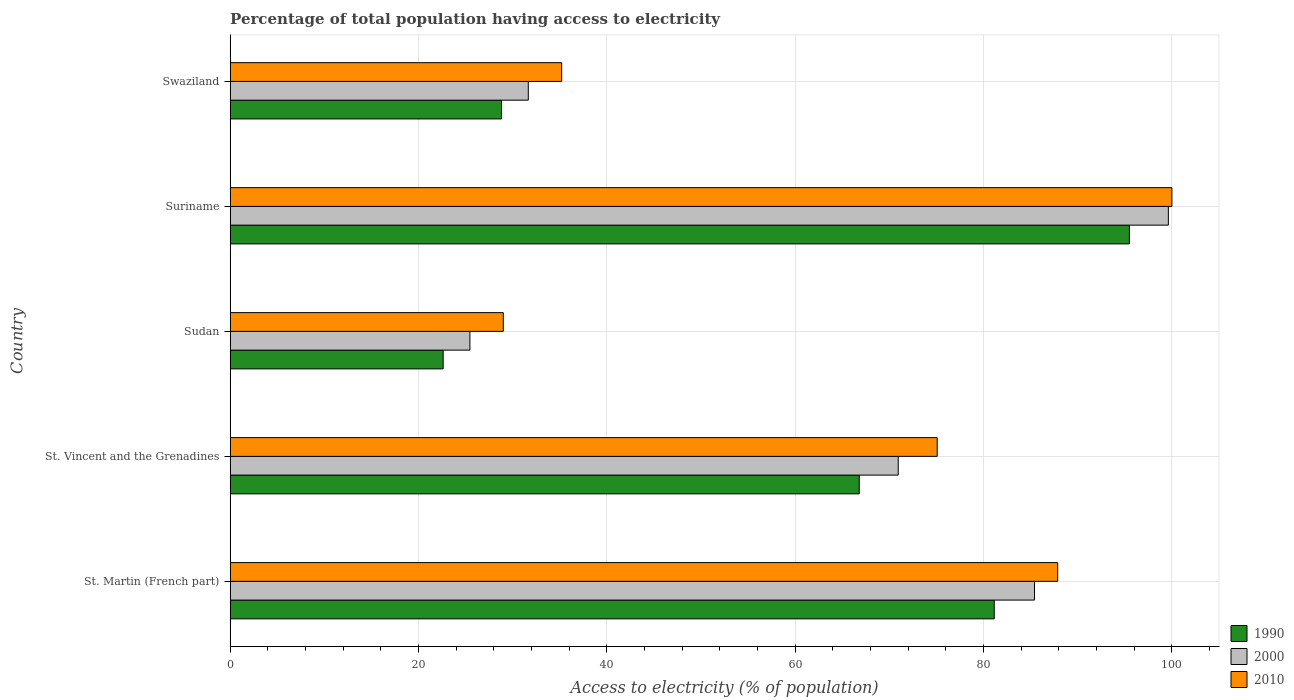How many bars are there on the 5th tick from the bottom?
Give a very brief answer. 3. What is the label of the 2nd group of bars from the top?
Give a very brief answer. Suriname. In how many cases, is the number of bars for a given country not equal to the number of legend labels?
Offer a very short reply. 0. What is the percentage of population that have access to electricity in 2000 in St. Vincent and the Grenadines?
Your response must be concise. 70.94. Across all countries, what is the maximum percentage of population that have access to electricity in 2010?
Offer a terse response. 100. Across all countries, what is the minimum percentage of population that have access to electricity in 1990?
Provide a short and direct response. 22.62. In which country was the percentage of population that have access to electricity in 1990 maximum?
Provide a succinct answer. Suriname. In which country was the percentage of population that have access to electricity in 2010 minimum?
Give a very brief answer. Sudan. What is the total percentage of population that have access to electricity in 1990 in the graph?
Offer a terse response. 294.85. What is the difference between the percentage of population that have access to electricity in 2010 in St. Vincent and the Grenadines and that in Suriname?
Give a very brief answer. -24.92. What is the difference between the percentage of population that have access to electricity in 1990 in Sudan and the percentage of population that have access to electricity in 2010 in St. Vincent and the Grenadines?
Make the answer very short. -52.46. What is the average percentage of population that have access to electricity in 2010 per country?
Offer a very short reply. 65.43. What is the difference between the percentage of population that have access to electricity in 1990 and percentage of population that have access to electricity in 2000 in St. Martin (French part)?
Make the answer very short. -4.28. What is the ratio of the percentage of population that have access to electricity in 2010 in Sudan to that in Suriname?
Make the answer very short. 0.29. Is the percentage of population that have access to electricity in 2010 in Suriname less than that in Swaziland?
Your answer should be very brief. No. What is the difference between the highest and the second highest percentage of population that have access to electricity in 1990?
Ensure brevity in your answer.  14.35. What is the difference between the highest and the lowest percentage of population that have access to electricity in 2010?
Give a very brief answer. 71. Is the sum of the percentage of population that have access to electricity in 2000 in St. Vincent and the Grenadines and Sudan greater than the maximum percentage of population that have access to electricity in 2010 across all countries?
Make the answer very short. No. What does the 1st bar from the top in Swaziland represents?
Make the answer very short. 2010. What does the 2nd bar from the bottom in St. Vincent and the Grenadines represents?
Your answer should be compact. 2000. Are all the bars in the graph horizontal?
Your answer should be very brief. Yes. What is the difference between two consecutive major ticks on the X-axis?
Provide a short and direct response. 20. Does the graph contain any zero values?
Your response must be concise. No. Where does the legend appear in the graph?
Make the answer very short. Bottom right. How are the legend labels stacked?
Make the answer very short. Vertical. What is the title of the graph?
Offer a terse response. Percentage of total population having access to electricity. What is the label or title of the X-axis?
Your answer should be very brief. Access to electricity (% of population). What is the Access to electricity (% of population) in 1990 in St. Martin (French part)?
Provide a short and direct response. 81.14. What is the Access to electricity (% of population) in 2000 in St. Martin (French part)?
Ensure brevity in your answer.  85.41. What is the Access to electricity (% of population) of 2010 in St. Martin (French part)?
Give a very brief answer. 87.87. What is the Access to electricity (% of population) of 1990 in St. Vincent and the Grenadines?
Keep it short and to the point. 66.8. What is the Access to electricity (% of population) in 2000 in St. Vincent and the Grenadines?
Your response must be concise. 70.94. What is the Access to electricity (% of population) in 2010 in St. Vincent and the Grenadines?
Provide a short and direct response. 75.08. What is the Access to electricity (% of population) in 1990 in Sudan?
Your response must be concise. 22.62. What is the Access to electricity (% of population) of 2000 in Sudan?
Your answer should be compact. 25.46. What is the Access to electricity (% of population) in 1990 in Suriname?
Keep it short and to the point. 95.49. What is the Access to electricity (% of population) in 2000 in Suriname?
Offer a very short reply. 99.62. What is the Access to electricity (% of population) of 2010 in Suriname?
Keep it short and to the point. 100. What is the Access to electricity (% of population) in 1990 in Swaziland?
Provide a succinct answer. 28.82. What is the Access to electricity (% of population) in 2000 in Swaziland?
Your answer should be very brief. 31.66. What is the Access to electricity (% of population) in 2010 in Swaziland?
Offer a very short reply. 35.2. Across all countries, what is the maximum Access to electricity (% of population) of 1990?
Your answer should be compact. 95.49. Across all countries, what is the maximum Access to electricity (% of population) in 2000?
Ensure brevity in your answer.  99.62. Across all countries, what is the minimum Access to electricity (% of population) in 1990?
Provide a short and direct response. 22.62. Across all countries, what is the minimum Access to electricity (% of population) in 2000?
Offer a terse response. 25.46. What is the total Access to electricity (% of population) in 1990 in the graph?
Provide a succinct answer. 294.85. What is the total Access to electricity (% of population) in 2000 in the graph?
Your answer should be very brief. 313.09. What is the total Access to electricity (% of population) in 2010 in the graph?
Your answer should be compact. 327.15. What is the difference between the Access to electricity (% of population) of 1990 in St. Martin (French part) and that in St. Vincent and the Grenadines?
Your answer should be compact. 14.34. What is the difference between the Access to electricity (% of population) of 2000 in St. Martin (French part) and that in St. Vincent and the Grenadines?
Ensure brevity in your answer.  14.47. What is the difference between the Access to electricity (% of population) in 2010 in St. Martin (French part) and that in St. Vincent and the Grenadines?
Give a very brief answer. 12.8. What is the difference between the Access to electricity (% of population) of 1990 in St. Martin (French part) and that in Sudan?
Your answer should be very brief. 58.52. What is the difference between the Access to electricity (% of population) in 2000 in St. Martin (French part) and that in Sudan?
Offer a terse response. 59.96. What is the difference between the Access to electricity (% of population) of 2010 in St. Martin (French part) and that in Sudan?
Ensure brevity in your answer.  58.87. What is the difference between the Access to electricity (% of population) in 1990 in St. Martin (French part) and that in Suriname?
Give a very brief answer. -14.35. What is the difference between the Access to electricity (% of population) in 2000 in St. Martin (French part) and that in Suriname?
Make the answer very short. -14.21. What is the difference between the Access to electricity (% of population) of 2010 in St. Martin (French part) and that in Suriname?
Keep it short and to the point. -12.13. What is the difference between the Access to electricity (% of population) of 1990 in St. Martin (French part) and that in Swaziland?
Ensure brevity in your answer.  52.32. What is the difference between the Access to electricity (% of population) of 2000 in St. Martin (French part) and that in Swaziland?
Keep it short and to the point. 53.76. What is the difference between the Access to electricity (% of population) of 2010 in St. Martin (French part) and that in Swaziland?
Your answer should be very brief. 52.67. What is the difference between the Access to electricity (% of population) in 1990 in St. Vincent and the Grenadines and that in Sudan?
Your answer should be compact. 44.18. What is the difference between the Access to electricity (% of population) of 2000 in St. Vincent and the Grenadines and that in Sudan?
Keep it short and to the point. 45.48. What is the difference between the Access to electricity (% of population) of 2010 in St. Vincent and the Grenadines and that in Sudan?
Your response must be concise. 46.08. What is the difference between the Access to electricity (% of population) in 1990 in St. Vincent and the Grenadines and that in Suriname?
Keep it short and to the point. -28.69. What is the difference between the Access to electricity (% of population) of 2000 in St. Vincent and the Grenadines and that in Suriname?
Offer a very short reply. -28.69. What is the difference between the Access to electricity (% of population) of 2010 in St. Vincent and the Grenadines and that in Suriname?
Provide a short and direct response. -24.92. What is the difference between the Access to electricity (% of population) in 1990 in St. Vincent and the Grenadines and that in Swaziland?
Make the answer very short. 37.98. What is the difference between the Access to electricity (% of population) in 2000 in St. Vincent and the Grenadines and that in Swaziland?
Your answer should be very brief. 39.28. What is the difference between the Access to electricity (% of population) of 2010 in St. Vincent and the Grenadines and that in Swaziland?
Your answer should be very brief. 39.88. What is the difference between the Access to electricity (% of population) in 1990 in Sudan and that in Suriname?
Provide a succinct answer. -72.87. What is the difference between the Access to electricity (% of population) in 2000 in Sudan and that in Suriname?
Ensure brevity in your answer.  -74.17. What is the difference between the Access to electricity (% of population) in 2010 in Sudan and that in Suriname?
Provide a succinct answer. -71. What is the difference between the Access to electricity (% of population) of 1990 in Sudan and that in Swaziland?
Offer a very short reply. -6.2. What is the difference between the Access to electricity (% of population) in 2000 in Sudan and that in Swaziland?
Ensure brevity in your answer.  -6.2. What is the difference between the Access to electricity (% of population) in 1990 in Suriname and that in Swaziland?
Ensure brevity in your answer.  66.67. What is the difference between the Access to electricity (% of population) of 2000 in Suriname and that in Swaziland?
Give a very brief answer. 67.97. What is the difference between the Access to electricity (% of population) of 2010 in Suriname and that in Swaziland?
Provide a short and direct response. 64.8. What is the difference between the Access to electricity (% of population) in 1990 in St. Martin (French part) and the Access to electricity (% of population) in 2000 in St. Vincent and the Grenadines?
Your answer should be compact. 10.2. What is the difference between the Access to electricity (% of population) in 1990 in St. Martin (French part) and the Access to electricity (% of population) in 2010 in St. Vincent and the Grenadines?
Provide a succinct answer. 6.06. What is the difference between the Access to electricity (% of population) of 2000 in St. Martin (French part) and the Access to electricity (% of population) of 2010 in St. Vincent and the Grenadines?
Ensure brevity in your answer.  10.33. What is the difference between the Access to electricity (% of population) of 1990 in St. Martin (French part) and the Access to electricity (% of population) of 2000 in Sudan?
Provide a short and direct response. 55.68. What is the difference between the Access to electricity (% of population) of 1990 in St. Martin (French part) and the Access to electricity (% of population) of 2010 in Sudan?
Give a very brief answer. 52.14. What is the difference between the Access to electricity (% of population) of 2000 in St. Martin (French part) and the Access to electricity (% of population) of 2010 in Sudan?
Ensure brevity in your answer.  56.41. What is the difference between the Access to electricity (% of population) in 1990 in St. Martin (French part) and the Access to electricity (% of population) in 2000 in Suriname?
Provide a succinct answer. -18.49. What is the difference between the Access to electricity (% of population) in 1990 in St. Martin (French part) and the Access to electricity (% of population) in 2010 in Suriname?
Your response must be concise. -18.86. What is the difference between the Access to electricity (% of population) of 2000 in St. Martin (French part) and the Access to electricity (% of population) of 2010 in Suriname?
Ensure brevity in your answer.  -14.59. What is the difference between the Access to electricity (% of population) of 1990 in St. Martin (French part) and the Access to electricity (% of population) of 2000 in Swaziland?
Your answer should be very brief. 49.48. What is the difference between the Access to electricity (% of population) of 1990 in St. Martin (French part) and the Access to electricity (% of population) of 2010 in Swaziland?
Make the answer very short. 45.94. What is the difference between the Access to electricity (% of population) in 2000 in St. Martin (French part) and the Access to electricity (% of population) in 2010 in Swaziland?
Provide a succinct answer. 50.21. What is the difference between the Access to electricity (% of population) in 1990 in St. Vincent and the Grenadines and the Access to electricity (% of population) in 2000 in Sudan?
Make the answer very short. 41.34. What is the difference between the Access to electricity (% of population) of 1990 in St. Vincent and the Grenadines and the Access to electricity (% of population) of 2010 in Sudan?
Keep it short and to the point. 37.8. What is the difference between the Access to electricity (% of population) of 2000 in St. Vincent and the Grenadines and the Access to electricity (% of population) of 2010 in Sudan?
Your answer should be compact. 41.94. What is the difference between the Access to electricity (% of population) of 1990 in St. Vincent and the Grenadines and the Access to electricity (% of population) of 2000 in Suriname?
Ensure brevity in your answer.  -32.82. What is the difference between the Access to electricity (% of population) in 1990 in St. Vincent and the Grenadines and the Access to electricity (% of population) in 2010 in Suriname?
Offer a very short reply. -33.2. What is the difference between the Access to electricity (% of population) of 2000 in St. Vincent and the Grenadines and the Access to electricity (% of population) of 2010 in Suriname?
Your answer should be very brief. -29.06. What is the difference between the Access to electricity (% of population) in 1990 in St. Vincent and the Grenadines and the Access to electricity (% of population) in 2000 in Swaziland?
Provide a short and direct response. 35.14. What is the difference between the Access to electricity (% of population) in 1990 in St. Vincent and the Grenadines and the Access to electricity (% of population) in 2010 in Swaziland?
Your answer should be compact. 31.6. What is the difference between the Access to electricity (% of population) in 2000 in St. Vincent and the Grenadines and the Access to electricity (% of population) in 2010 in Swaziland?
Your response must be concise. 35.74. What is the difference between the Access to electricity (% of population) in 1990 in Sudan and the Access to electricity (% of population) in 2000 in Suriname?
Make the answer very short. -77.01. What is the difference between the Access to electricity (% of population) of 1990 in Sudan and the Access to electricity (% of population) of 2010 in Suriname?
Provide a succinct answer. -77.38. What is the difference between the Access to electricity (% of population) in 2000 in Sudan and the Access to electricity (% of population) in 2010 in Suriname?
Give a very brief answer. -74.54. What is the difference between the Access to electricity (% of population) of 1990 in Sudan and the Access to electricity (% of population) of 2000 in Swaziland?
Keep it short and to the point. -9.04. What is the difference between the Access to electricity (% of population) in 1990 in Sudan and the Access to electricity (% of population) in 2010 in Swaziland?
Keep it short and to the point. -12.58. What is the difference between the Access to electricity (% of population) of 2000 in Sudan and the Access to electricity (% of population) of 2010 in Swaziland?
Provide a succinct answer. -9.74. What is the difference between the Access to electricity (% of population) in 1990 in Suriname and the Access to electricity (% of population) in 2000 in Swaziland?
Give a very brief answer. 63.83. What is the difference between the Access to electricity (% of population) in 1990 in Suriname and the Access to electricity (% of population) in 2010 in Swaziland?
Keep it short and to the point. 60.29. What is the difference between the Access to electricity (% of population) of 2000 in Suriname and the Access to electricity (% of population) of 2010 in Swaziland?
Your answer should be compact. 64.42. What is the average Access to electricity (% of population) in 1990 per country?
Keep it short and to the point. 58.97. What is the average Access to electricity (% of population) in 2000 per country?
Make the answer very short. 62.62. What is the average Access to electricity (% of population) in 2010 per country?
Provide a short and direct response. 65.43. What is the difference between the Access to electricity (% of population) in 1990 and Access to electricity (% of population) in 2000 in St. Martin (French part)?
Your answer should be compact. -4.28. What is the difference between the Access to electricity (% of population) in 1990 and Access to electricity (% of population) in 2010 in St. Martin (French part)?
Provide a succinct answer. -6.74. What is the difference between the Access to electricity (% of population) of 2000 and Access to electricity (% of population) of 2010 in St. Martin (French part)?
Give a very brief answer. -2.46. What is the difference between the Access to electricity (% of population) in 1990 and Access to electricity (% of population) in 2000 in St. Vincent and the Grenadines?
Keep it short and to the point. -4.14. What is the difference between the Access to electricity (% of population) in 1990 and Access to electricity (% of population) in 2010 in St. Vincent and the Grenadines?
Make the answer very short. -8.28. What is the difference between the Access to electricity (% of population) of 2000 and Access to electricity (% of population) of 2010 in St. Vincent and the Grenadines?
Offer a very short reply. -4.14. What is the difference between the Access to electricity (% of population) in 1990 and Access to electricity (% of population) in 2000 in Sudan?
Your answer should be compact. -2.84. What is the difference between the Access to electricity (% of population) of 1990 and Access to electricity (% of population) of 2010 in Sudan?
Your response must be concise. -6.38. What is the difference between the Access to electricity (% of population) of 2000 and Access to electricity (% of population) of 2010 in Sudan?
Give a very brief answer. -3.54. What is the difference between the Access to electricity (% of population) in 1990 and Access to electricity (% of population) in 2000 in Suriname?
Ensure brevity in your answer.  -4.14. What is the difference between the Access to electricity (% of population) of 1990 and Access to electricity (% of population) of 2010 in Suriname?
Provide a succinct answer. -4.51. What is the difference between the Access to electricity (% of population) in 2000 and Access to electricity (% of population) in 2010 in Suriname?
Provide a short and direct response. -0.38. What is the difference between the Access to electricity (% of population) of 1990 and Access to electricity (% of population) of 2000 in Swaziland?
Give a very brief answer. -2.84. What is the difference between the Access to electricity (% of population) of 1990 and Access to electricity (% of population) of 2010 in Swaziland?
Ensure brevity in your answer.  -6.38. What is the difference between the Access to electricity (% of population) of 2000 and Access to electricity (% of population) of 2010 in Swaziland?
Your answer should be very brief. -3.54. What is the ratio of the Access to electricity (% of population) in 1990 in St. Martin (French part) to that in St. Vincent and the Grenadines?
Offer a terse response. 1.21. What is the ratio of the Access to electricity (% of population) of 2000 in St. Martin (French part) to that in St. Vincent and the Grenadines?
Keep it short and to the point. 1.2. What is the ratio of the Access to electricity (% of population) in 2010 in St. Martin (French part) to that in St. Vincent and the Grenadines?
Your answer should be very brief. 1.17. What is the ratio of the Access to electricity (% of population) of 1990 in St. Martin (French part) to that in Sudan?
Make the answer very short. 3.59. What is the ratio of the Access to electricity (% of population) of 2000 in St. Martin (French part) to that in Sudan?
Offer a very short reply. 3.36. What is the ratio of the Access to electricity (% of population) of 2010 in St. Martin (French part) to that in Sudan?
Offer a very short reply. 3.03. What is the ratio of the Access to electricity (% of population) in 1990 in St. Martin (French part) to that in Suriname?
Your answer should be very brief. 0.85. What is the ratio of the Access to electricity (% of population) in 2000 in St. Martin (French part) to that in Suriname?
Offer a very short reply. 0.86. What is the ratio of the Access to electricity (% of population) of 2010 in St. Martin (French part) to that in Suriname?
Your response must be concise. 0.88. What is the ratio of the Access to electricity (% of population) in 1990 in St. Martin (French part) to that in Swaziland?
Give a very brief answer. 2.82. What is the ratio of the Access to electricity (% of population) in 2000 in St. Martin (French part) to that in Swaziland?
Provide a succinct answer. 2.7. What is the ratio of the Access to electricity (% of population) of 2010 in St. Martin (French part) to that in Swaziland?
Offer a very short reply. 2.5. What is the ratio of the Access to electricity (% of population) in 1990 in St. Vincent and the Grenadines to that in Sudan?
Give a very brief answer. 2.95. What is the ratio of the Access to electricity (% of population) of 2000 in St. Vincent and the Grenadines to that in Sudan?
Your response must be concise. 2.79. What is the ratio of the Access to electricity (% of population) in 2010 in St. Vincent and the Grenadines to that in Sudan?
Give a very brief answer. 2.59. What is the ratio of the Access to electricity (% of population) of 1990 in St. Vincent and the Grenadines to that in Suriname?
Your answer should be compact. 0.7. What is the ratio of the Access to electricity (% of population) of 2000 in St. Vincent and the Grenadines to that in Suriname?
Keep it short and to the point. 0.71. What is the ratio of the Access to electricity (% of population) in 2010 in St. Vincent and the Grenadines to that in Suriname?
Your answer should be compact. 0.75. What is the ratio of the Access to electricity (% of population) of 1990 in St. Vincent and the Grenadines to that in Swaziland?
Provide a succinct answer. 2.32. What is the ratio of the Access to electricity (% of population) of 2000 in St. Vincent and the Grenadines to that in Swaziland?
Your response must be concise. 2.24. What is the ratio of the Access to electricity (% of population) in 2010 in St. Vincent and the Grenadines to that in Swaziland?
Provide a succinct answer. 2.13. What is the ratio of the Access to electricity (% of population) of 1990 in Sudan to that in Suriname?
Your answer should be compact. 0.24. What is the ratio of the Access to electricity (% of population) in 2000 in Sudan to that in Suriname?
Keep it short and to the point. 0.26. What is the ratio of the Access to electricity (% of population) in 2010 in Sudan to that in Suriname?
Ensure brevity in your answer.  0.29. What is the ratio of the Access to electricity (% of population) in 1990 in Sudan to that in Swaziland?
Your response must be concise. 0.78. What is the ratio of the Access to electricity (% of population) in 2000 in Sudan to that in Swaziland?
Make the answer very short. 0.8. What is the ratio of the Access to electricity (% of population) in 2010 in Sudan to that in Swaziland?
Provide a succinct answer. 0.82. What is the ratio of the Access to electricity (% of population) of 1990 in Suriname to that in Swaziland?
Your answer should be compact. 3.31. What is the ratio of the Access to electricity (% of population) in 2000 in Suriname to that in Swaziland?
Offer a very short reply. 3.15. What is the ratio of the Access to electricity (% of population) of 2010 in Suriname to that in Swaziland?
Make the answer very short. 2.84. What is the difference between the highest and the second highest Access to electricity (% of population) of 1990?
Make the answer very short. 14.35. What is the difference between the highest and the second highest Access to electricity (% of population) of 2000?
Offer a very short reply. 14.21. What is the difference between the highest and the second highest Access to electricity (% of population) of 2010?
Ensure brevity in your answer.  12.13. What is the difference between the highest and the lowest Access to electricity (% of population) in 1990?
Provide a short and direct response. 72.87. What is the difference between the highest and the lowest Access to electricity (% of population) of 2000?
Provide a succinct answer. 74.17. 